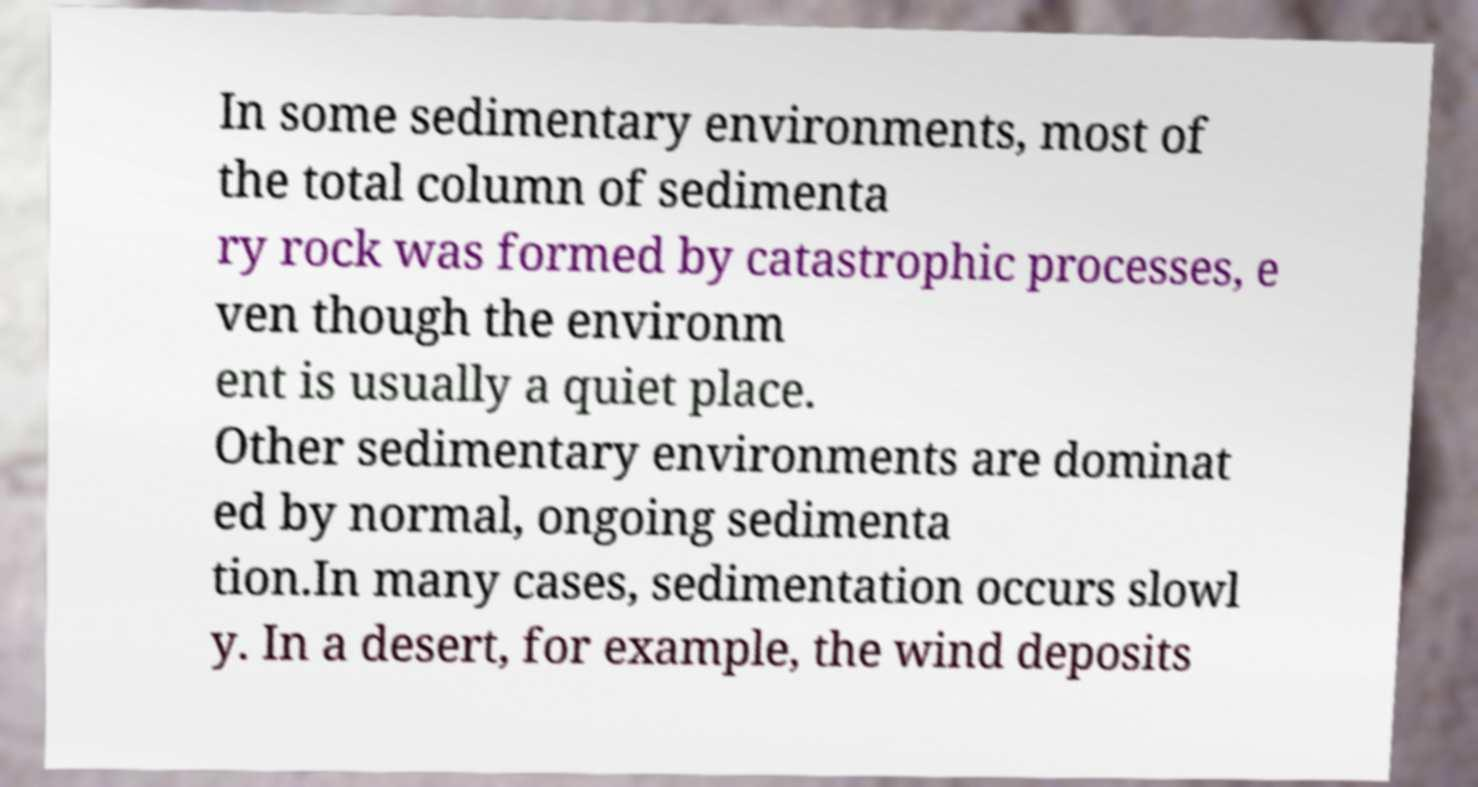Could you assist in decoding the text presented in this image and type it out clearly? In some sedimentary environments, most of the total column of sedimenta ry rock was formed by catastrophic processes, e ven though the environm ent is usually a quiet place. Other sedimentary environments are dominat ed by normal, ongoing sedimenta tion.In many cases, sedimentation occurs slowl y. In a desert, for example, the wind deposits 